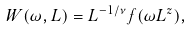Convert formula to latex. <formula><loc_0><loc_0><loc_500><loc_500>W ( \omega , L ) = L ^ { - 1 / \nu } f ( \omega L ^ { z } ) ,</formula> 